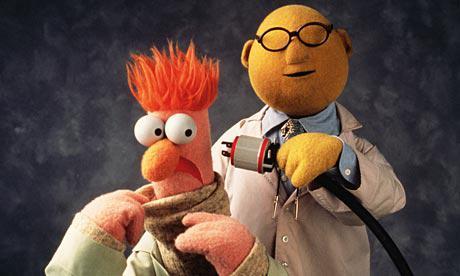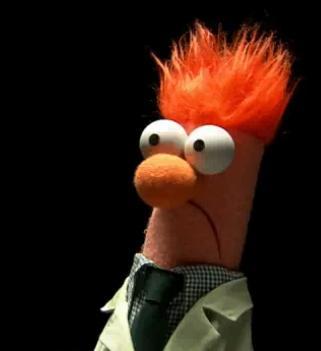The first image is the image on the left, the second image is the image on the right. Examine the images to the left and right. Is the description "The puppet is facing to the right in the image on the right." accurate? Answer yes or no. No. 